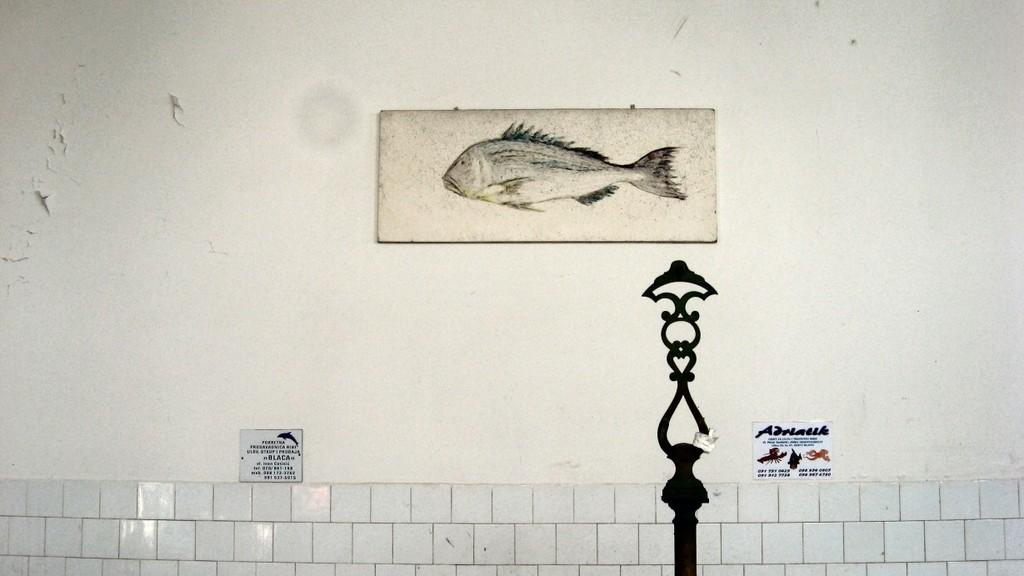What is present on the wall in the image? There is a wall in the image, and on it, there are stickers and a frame. What is inside the frame on the wall? There is a painting inside the frame on the wall. What type of ink is used in the painting on the wall? There is no information about the type of ink used in the painting, as it is not mentioned in the facts. Additionally, the type of ink used in a painting is not something that can be determined from an image alone. 